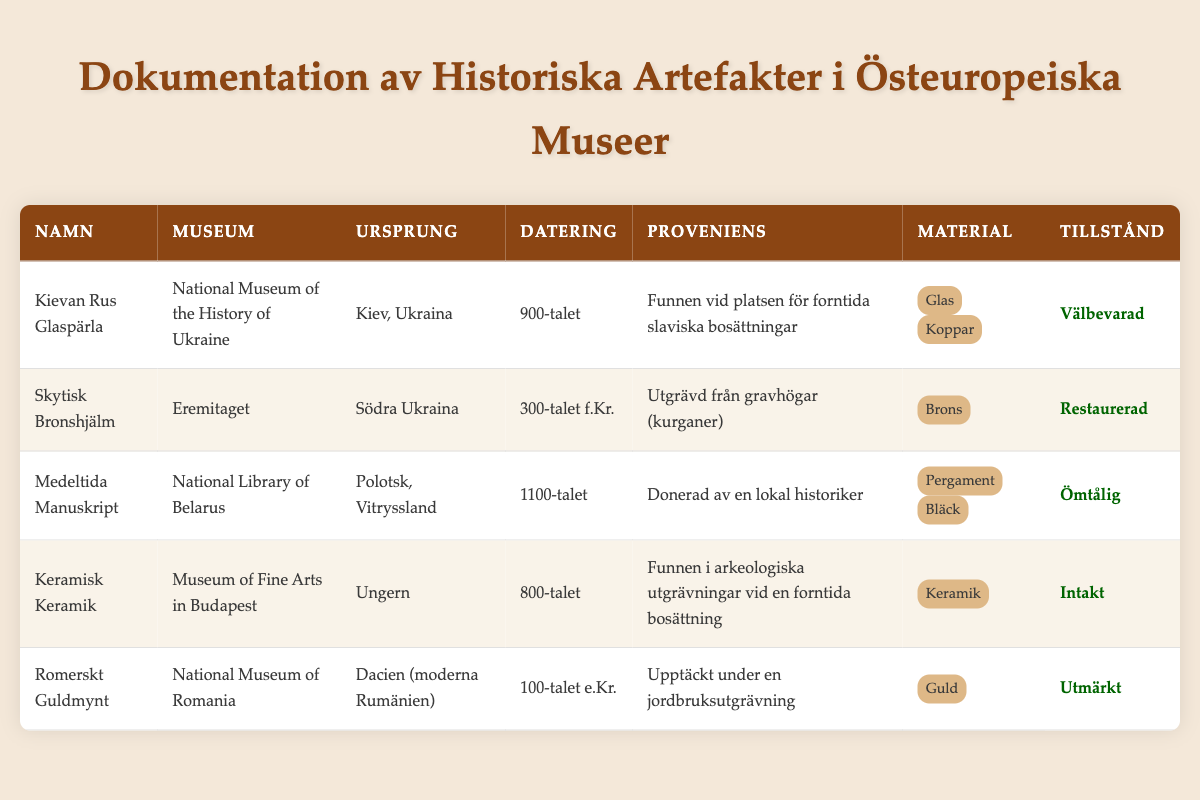What is the origin of the Kievan Rus Glass Bead? The table lists the Kievan Rus Glass Bead under the "Ursprung" column as "Kiev, Ukraina."
Answer: Kiev, Ukraina Which artifact is described as "Ömtålig"? Looking at the "Tillstånd" column, the only artifact noted as "Ömtålig" is the Medieval Manuscript from the National Library of Belarus.
Answer: Medieval Manuscript How many artifacts were found at burial mounds (kurgans)? According to the table, only the Bronze Scythian Helmet is noted to have been excavated from burial mounds (kurgans). Therefore, the count is one.
Answer: 1 What materials are used in the Ceramic Pottery? The Ceramic Pottery is listed under the "Material" column with one entry: "Keramik," indicating it is made solely of ceramic.
Answer: Keramik Is the Roman Gold Coin in excellent condition? The table indicates the Roman Gold Coin is noted as "Utmärkt" under the "Tillstånd" column, confirming it is indeed in excellent condition.
Answer: Yes What is the earliest artifact listed, and what is its date? The table shows the Bronze Scythian Helmet as the earliest artifact with a date of "300-talet f.Kr.," while the others are from later periods.
Answer: Bronze Scythian Helmet, 4th Century BC How many artifacts are categorized as "Välbevarad"? By examining the "Tillstånd" column, the Kievan Rus Glass Bead is the only artifact categorized as "Välbevarad"; thus, there is one.
Answer: 1 Which museum houses the Medieval Manuscript? The table provides that the Medieval Manuscript can be found in the National Library of Belarus, as stated in the "Museum" column.
Answer: National Library of Belarus Are there any artifacts from the 12th Century? Yes, the Medieval Manuscript is listed as originating from the 12th Century, confirming there is at least one artifact from that time.
Answer: Yes 